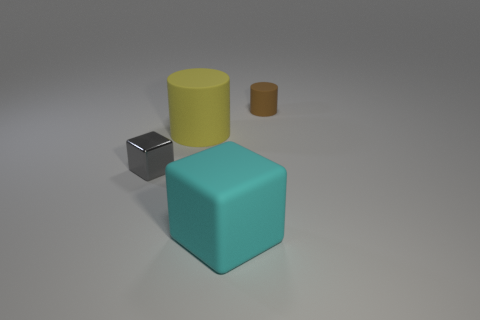Add 2 yellow things. How many objects exist? 6 Add 1 rubber things. How many rubber things are left? 4 Add 3 big cyan blocks. How many big cyan blocks exist? 4 Subtract 0 gray cylinders. How many objects are left? 4 Subtract all yellow metallic cylinders. Subtract all cubes. How many objects are left? 2 